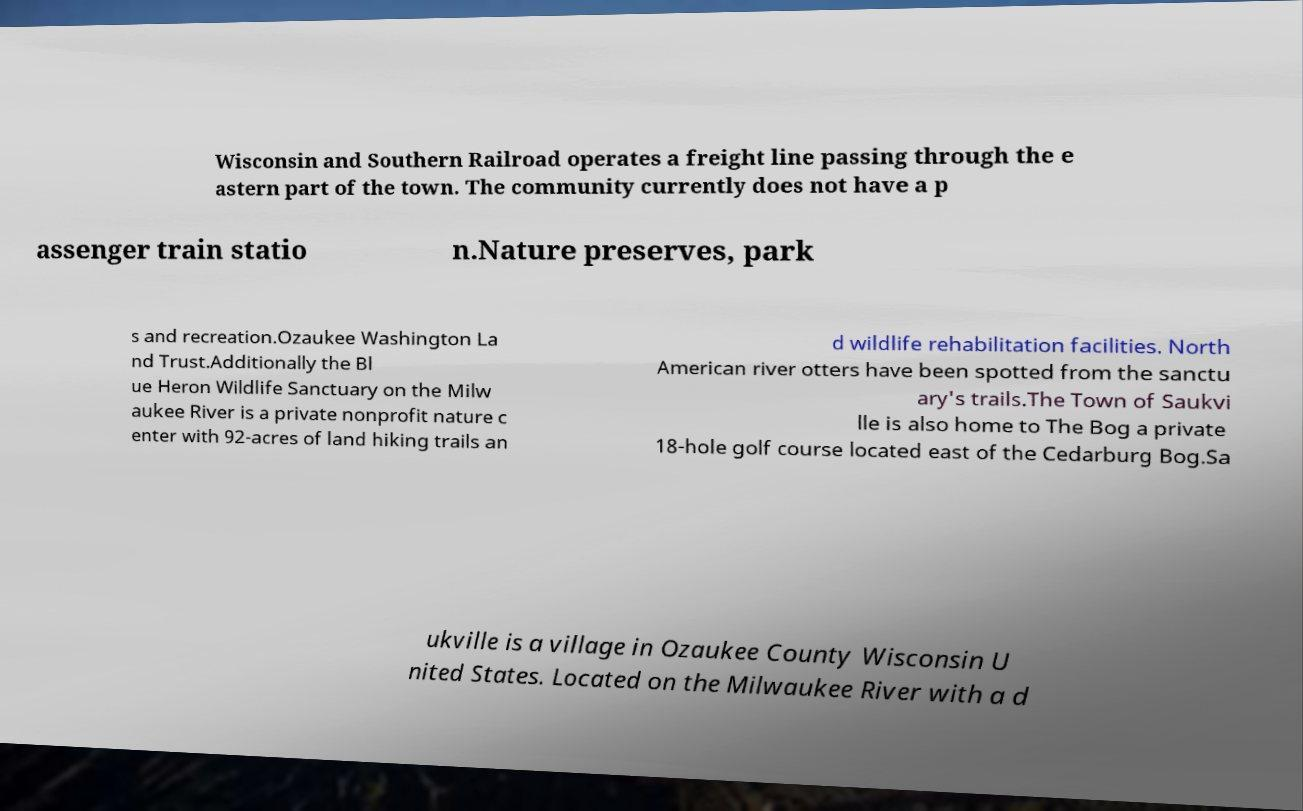Please identify and transcribe the text found in this image. Wisconsin and Southern Railroad operates a freight line passing through the e astern part of the town. The community currently does not have a p assenger train statio n.Nature preserves, park s and recreation.Ozaukee Washington La nd Trust.Additionally the Bl ue Heron Wildlife Sanctuary on the Milw aukee River is a private nonprofit nature c enter with 92-acres of land hiking trails an d wildlife rehabilitation facilities. North American river otters have been spotted from the sanctu ary's trails.The Town of Saukvi lle is also home to The Bog a private 18-hole golf course located east of the Cedarburg Bog.Sa ukville is a village in Ozaukee County Wisconsin U nited States. Located on the Milwaukee River with a d 